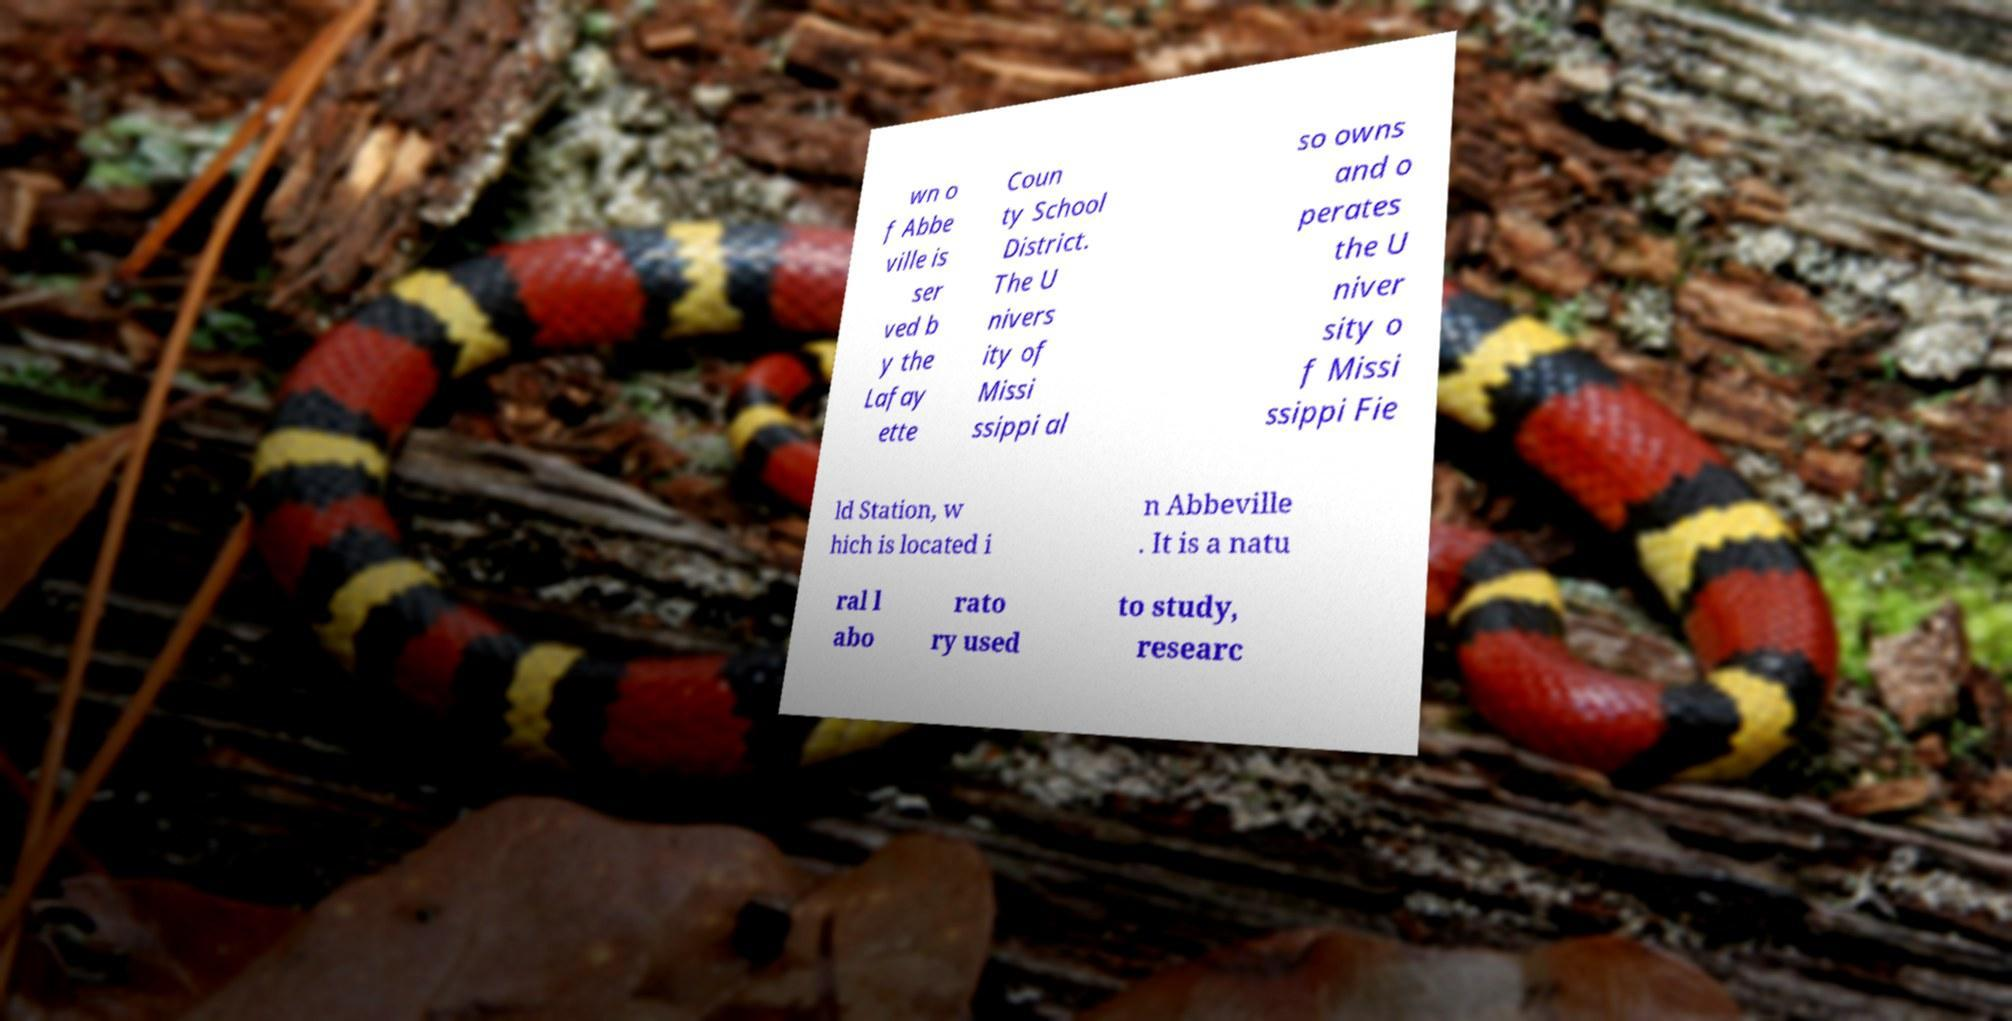Please identify and transcribe the text found in this image. wn o f Abbe ville is ser ved b y the Lafay ette Coun ty School District. The U nivers ity of Missi ssippi al so owns and o perates the U niver sity o f Missi ssippi Fie ld Station, w hich is located i n Abbeville . It is a natu ral l abo rato ry used to study, researc 